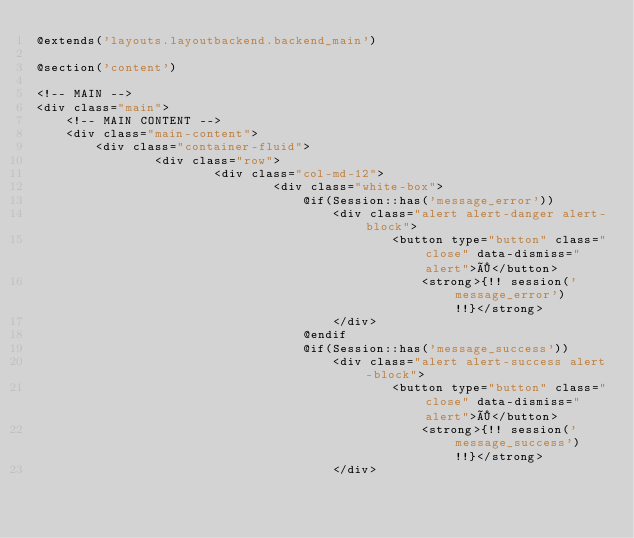<code> <loc_0><loc_0><loc_500><loc_500><_PHP_>@extends('layouts.layoutbackend.backend_main')

@section('content')

<!-- MAIN -->
<div class="main">
    <!-- MAIN CONTENT -->
    <div class="main-content">
        <div class="container-fluid">
                <div class="row">
                        <div class="col-md-12">
                                <div class="white-box">
                                    @if(Session::has('message_error'))
                                        <div class="alert alert-danger alert-block">
                                                <button type="button" class="close" data-dismiss="alert">×</button>	
                                                    <strong>{!! session('message_error') !!}</strong>
                                        </div>
                                    @endif
                                    @if(Session::has('message_success'))
                                        <div class="alert alert-success alert-block">
                                                <button type="button" class="close" data-dismiss="alert">×</button>	
                                                    <strong>{!! session('message_success') !!}</strong>
                                        </div></code> 